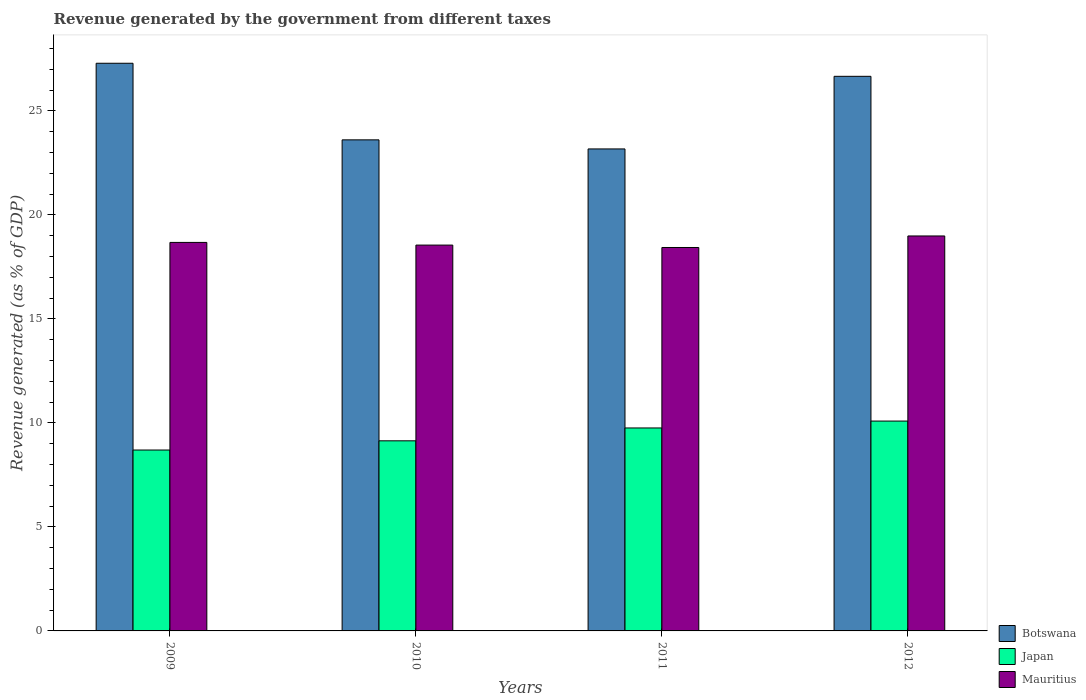Are the number of bars per tick equal to the number of legend labels?
Your answer should be very brief. Yes. Are the number of bars on each tick of the X-axis equal?
Offer a very short reply. Yes. How many bars are there on the 3rd tick from the right?
Offer a very short reply. 3. What is the label of the 1st group of bars from the left?
Give a very brief answer. 2009. In how many cases, is the number of bars for a given year not equal to the number of legend labels?
Make the answer very short. 0. What is the revenue generated by the government in Mauritius in 2009?
Provide a succinct answer. 18.67. Across all years, what is the maximum revenue generated by the government in Botswana?
Make the answer very short. 27.29. Across all years, what is the minimum revenue generated by the government in Botswana?
Ensure brevity in your answer.  23.17. In which year was the revenue generated by the government in Mauritius minimum?
Your answer should be compact. 2011. What is the total revenue generated by the government in Mauritius in the graph?
Provide a short and direct response. 74.64. What is the difference between the revenue generated by the government in Japan in 2010 and that in 2011?
Give a very brief answer. -0.62. What is the difference between the revenue generated by the government in Japan in 2009 and the revenue generated by the government in Mauritius in 2012?
Offer a terse response. -10.29. What is the average revenue generated by the government in Japan per year?
Provide a succinct answer. 9.42. In the year 2009, what is the difference between the revenue generated by the government in Botswana and revenue generated by the government in Mauritius?
Offer a very short reply. 8.61. What is the ratio of the revenue generated by the government in Mauritius in 2009 to that in 2011?
Ensure brevity in your answer.  1.01. What is the difference between the highest and the second highest revenue generated by the government in Botswana?
Give a very brief answer. 0.63. What is the difference between the highest and the lowest revenue generated by the government in Botswana?
Provide a succinct answer. 4.12. Is the sum of the revenue generated by the government in Mauritius in 2010 and 2012 greater than the maximum revenue generated by the government in Botswana across all years?
Keep it short and to the point. Yes. What does the 1st bar from the left in 2011 represents?
Give a very brief answer. Botswana. What does the 3rd bar from the right in 2012 represents?
Your answer should be compact. Botswana. Is it the case that in every year, the sum of the revenue generated by the government in Japan and revenue generated by the government in Botswana is greater than the revenue generated by the government in Mauritius?
Your answer should be very brief. Yes. How many bars are there?
Keep it short and to the point. 12. How many years are there in the graph?
Offer a terse response. 4. Does the graph contain grids?
Give a very brief answer. No. Where does the legend appear in the graph?
Give a very brief answer. Bottom right. What is the title of the graph?
Your response must be concise. Revenue generated by the government from different taxes. What is the label or title of the Y-axis?
Give a very brief answer. Revenue generated (as % of GDP). What is the Revenue generated (as % of GDP) in Botswana in 2009?
Offer a very short reply. 27.29. What is the Revenue generated (as % of GDP) in Japan in 2009?
Provide a succinct answer. 8.7. What is the Revenue generated (as % of GDP) in Mauritius in 2009?
Ensure brevity in your answer.  18.67. What is the Revenue generated (as % of GDP) in Botswana in 2010?
Give a very brief answer. 23.6. What is the Revenue generated (as % of GDP) in Japan in 2010?
Provide a short and direct response. 9.14. What is the Revenue generated (as % of GDP) of Mauritius in 2010?
Provide a short and direct response. 18.55. What is the Revenue generated (as % of GDP) in Botswana in 2011?
Offer a very short reply. 23.17. What is the Revenue generated (as % of GDP) in Japan in 2011?
Keep it short and to the point. 9.76. What is the Revenue generated (as % of GDP) in Mauritius in 2011?
Keep it short and to the point. 18.43. What is the Revenue generated (as % of GDP) of Botswana in 2012?
Offer a very short reply. 26.66. What is the Revenue generated (as % of GDP) of Japan in 2012?
Your answer should be compact. 10.09. What is the Revenue generated (as % of GDP) of Mauritius in 2012?
Offer a terse response. 18.98. Across all years, what is the maximum Revenue generated (as % of GDP) in Botswana?
Provide a short and direct response. 27.29. Across all years, what is the maximum Revenue generated (as % of GDP) in Japan?
Your answer should be very brief. 10.09. Across all years, what is the maximum Revenue generated (as % of GDP) of Mauritius?
Your response must be concise. 18.98. Across all years, what is the minimum Revenue generated (as % of GDP) in Botswana?
Offer a very short reply. 23.17. Across all years, what is the minimum Revenue generated (as % of GDP) in Japan?
Your response must be concise. 8.7. Across all years, what is the minimum Revenue generated (as % of GDP) of Mauritius?
Offer a terse response. 18.43. What is the total Revenue generated (as % of GDP) in Botswana in the graph?
Keep it short and to the point. 100.72. What is the total Revenue generated (as % of GDP) in Japan in the graph?
Your response must be concise. 37.68. What is the total Revenue generated (as % of GDP) in Mauritius in the graph?
Your answer should be compact. 74.64. What is the difference between the Revenue generated (as % of GDP) of Botswana in 2009 and that in 2010?
Your answer should be very brief. 3.68. What is the difference between the Revenue generated (as % of GDP) of Japan in 2009 and that in 2010?
Your answer should be very brief. -0.44. What is the difference between the Revenue generated (as % of GDP) in Mauritius in 2009 and that in 2010?
Make the answer very short. 0.13. What is the difference between the Revenue generated (as % of GDP) in Botswana in 2009 and that in 2011?
Provide a short and direct response. 4.12. What is the difference between the Revenue generated (as % of GDP) of Japan in 2009 and that in 2011?
Make the answer very short. -1.06. What is the difference between the Revenue generated (as % of GDP) in Mauritius in 2009 and that in 2011?
Your answer should be very brief. 0.24. What is the difference between the Revenue generated (as % of GDP) of Botswana in 2009 and that in 2012?
Make the answer very short. 0.63. What is the difference between the Revenue generated (as % of GDP) in Japan in 2009 and that in 2012?
Give a very brief answer. -1.39. What is the difference between the Revenue generated (as % of GDP) in Mauritius in 2009 and that in 2012?
Provide a succinct answer. -0.31. What is the difference between the Revenue generated (as % of GDP) of Botswana in 2010 and that in 2011?
Provide a short and direct response. 0.44. What is the difference between the Revenue generated (as % of GDP) in Japan in 2010 and that in 2011?
Offer a very short reply. -0.62. What is the difference between the Revenue generated (as % of GDP) in Mauritius in 2010 and that in 2011?
Ensure brevity in your answer.  0.12. What is the difference between the Revenue generated (as % of GDP) of Botswana in 2010 and that in 2012?
Provide a short and direct response. -3.05. What is the difference between the Revenue generated (as % of GDP) of Japan in 2010 and that in 2012?
Provide a short and direct response. -0.95. What is the difference between the Revenue generated (as % of GDP) in Mauritius in 2010 and that in 2012?
Your response must be concise. -0.44. What is the difference between the Revenue generated (as % of GDP) in Botswana in 2011 and that in 2012?
Your answer should be very brief. -3.49. What is the difference between the Revenue generated (as % of GDP) of Japan in 2011 and that in 2012?
Your response must be concise. -0.33. What is the difference between the Revenue generated (as % of GDP) of Mauritius in 2011 and that in 2012?
Your response must be concise. -0.55. What is the difference between the Revenue generated (as % of GDP) in Botswana in 2009 and the Revenue generated (as % of GDP) in Japan in 2010?
Give a very brief answer. 18.15. What is the difference between the Revenue generated (as % of GDP) of Botswana in 2009 and the Revenue generated (as % of GDP) of Mauritius in 2010?
Give a very brief answer. 8.74. What is the difference between the Revenue generated (as % of GDP) of Japan in 2009 and the Revenue generated (as % of GDP) of Mauritius in 2010?
Keep it short and to the point. -9.85. What is the difference between the Revenue generated (as % of GDP) of Botswana in 2009 and the Revenue generated (as % of GDP) of Japan in 2011?
Offer a terse response. 17.53. What is the difference between the Revenue generated (as % of GDP) in Botswana in 2009 and the Revenue generated (as % of GDP) in Mauritius in 2011?
Your response must be concise. 8.86. What is the difference between the Revenue generated (as % of GDP) of Japan in 2009 and the Revenue generated (as % of GDP) of Mauritius in 2011?
Offer a terse response. -9.74. What is the difference between the Revenue generated (as % of GDP) of Botswana in 2009 and the Revenue generated (as % of GDP) of Japan in 2012?
Offer a very short reply. 17.2. What is the difference between the Revenue generated (as % of GDP) in Botswana in 2009 and the Revenue generated (as % of GDP) in Mauritius in 2012?
Your answer should be compact. 8.3. What is the difference between the Revenue generated (as % of GDP) in Japan in 2009 and the Revenue generated (as % of GDP) in Mauritius in 2012?
Make the answer very short. -10.29. What is the difference between the Revenue generated (as % of GDP) of Botswana in 2010 and the Revenue generated (as % of GDP) of Japan in 2011?
Ensure brevity in your answer.  13.85. What is the difference between the Revenue generated (as % of GDP) of Botswana in 2010 and the Revenue generated (as % of GDP) of Mauritius in 2011?
Your answer should be very brief. 5.17. What is the difference between the Revenue generated (as % of GDP) in Japan in 2010 and the Revenue generated (as % of GDP) in Mauritius in 2011?
Offer a terse response. -9.29. What is the difference between the Revenue generated (as % of GDP) of Botswana in 2010 and the Revenue generated (as % of GDP) of Japan in 2012?
Offer a terse response. 13.52. What is the difference between the Revenue generated (as % of GDP) of Botswana in 2010 and the Revenue generated (as % of GDP) of Mauritius in 2012?
Make the answer very short. 4.62. What is the difference between the Revenue generated (as % of GDP) of Japan in 2010 and the Revenue generated (as % of GDP) of Mauritius in 2012?
Keep it short and to the point. -9.85. What is the difference between the Revenue generated (as % of GDP) in Botswana in 2011 and the Revenue generated (as % of GDP) in Japan in 2012?
Your answer should be very brief. 13.08. What is the difference between the Revenue generated (as % of GDP) in Botswana in 2011 and the Revenue generated (as % of GDP) in Mauritius in 2012?
Provide a short and direct response. 4.18. What is the difference between the Revenue generated (as % of GDP) of Japan in 2011 and the Revenue generated (as % of GDP) of Mauritius in 2012?
Make the answer very short. -9.23. What is the average Revenue generated (as % of GDP) in Botswana per year?
Provide a short and direct response. 25.18. What is the average Revenue generated (as % of GDP) of Japan per year?
Your answer should be very brief. 9.42. What is the average Revenue generated (as % of GDP) in Mauritius per year?
Make the answer very short. 18.66. In the year 2009, what is the difference between the Revenue generated (as % of GDP) in Botswana and Revenue generated (as % of GDP) in Japan?
Keep it short and to the point. 18.59. In the year 2009, what is the difference between the Revenue generated (as % of GDP) of Botswana and Revenue generated (as % of GDP) of Mauritius?
Ensure brevity in your answer.  8.61. In the year 2009, what is the difference between the Revenue generated (as % of GDP) of Japan and Revenue generated (as % of GDP) of Mauritius?
Keep it short and to the point. -9.98. In the year 2010, what is the difference between the Revenue generated (as % of GDP) of Botswana and Revenue generated (as % of GDP) of Japan?
Your answer should be very brief. 14.47. In the year 2010, what is the difference between the Revenue generated (as % of GDP) in Botswana and Revenue generated (as % of GDP) in Mauritius?
Ensure brevity in your answer.  5.06. In the year 2010, what is the difference between the Revenue generated (as % of GDP) in Japan and Revenue generated (as % of GDP) in Mauritius?
Keep it short and to the point. -9.41. In the year 2011, what is the difference between the Revenue generated (as % of GDP) of Botswana and Revenue generated (as % of GDP) of Japan?
Ensure brevity in your answer.  13.41. In the year 2011, what is the difference between the Revenue generated (as % of GDP) in Botswana and Revenue generated (as % of GDP) in Mauritius?
Give a very brief answer. 4.74. In the year 2011, what is the difference between the Revenue generated (as % of GDP) of Japan and Revenue generated (as % of GDP) of Mauritius?
Ensure brevity in your answer.  -8.67. In the year 2012, what is the difference between the Revenue generated (as % of GDP) of Botswana and Revenue generated (as % of GDP) of Japan?
Offer a terse response. 16.57. In the year 2012, what is the difference between the Revenue generated (as % of GDP) in Botswana and Revenue generated (as % of GDP) in Mauritius?
Your answer should be compact. 7.67. In the year 2012, what is the difference between the Revenue generated (as % of GDP) of Japan and Revenue generated (as % of GDP) of Mauritius?
Offer a terse response. -8.9. What is the ratio of the Revenue generated (as % of GDP) of Botswana in 2009 to that in 2010?
Ensure brevity in your answer.  1.16. What is the ratio of the Revenue generated (as % of GDP) of Japan in 2009 to that in 2010?
Ensure brevity in your answer.  0.95. What is the ratio of the Revenue generated (as % of GDP) in Mauritius in 2009 to that in 2010?
Give a very brief answer. 1.01. What is the ratio of the Revenue generated (as % of GDP) of Botswana in 2009 to that in 2011?
Make the answer very short. 1.18. What is the ratio of the Revenue generated (as % of GDP) in Japan in 2009 to that in 2011?
Ensure brevity in your answer.  0.89. What is the ratio of the Revenue generated (as % of GDP) of Mauritius in 2009 to that in 2011?
Provide a short and direct response. 1.01. What is the ratio of the Revenue generated (as % of GDP) of Botswana in 2009 to that in 2012?
Keep it short and to the point. 1.02. What is the ratio of the Revenue generated (as % of GDP) of Japan in 2009 to that in 2012?
Make the answer very short. 0.86. What is the ratio of the Revenue generated (as % of GDP) of Mauritius in 2009 to that in 2012?
Give a very brief answer. 0.98. What is the ratio of the Revenue generated (as % of GDP) in Botswana in 2010 to that in 2011?
Give a very brief answer. 1.02. What is the ratio of the Revenue generated (as % of GDP) of Japan in 2010 to that in 2011?
Your answer should be compact. 0.94. What is the ratio of the Revenue generated (as % of GDP) in Botswana in 2010 to that in 2012?
Offer a terse response. 0.89. What is the ratio of the Revenue generated (as % of GDP) in Japan in 2010 to that in 2012?
Your answer should be very brief. 0.91. What is the ratio of the Revenue generated (as % of GDP) of Mauritius in 2010 to that in 2012?
Provide a succinct answer. 0.98. What is the ratio of the Revenue generated (as % of GDP) of Botswana in 2011 to that in 2012?
Offer a terse response. 0.87. What is the ratio of the Revenue generated (as % of GDP) of Japan in 2011 to that in 2012?
Your response must be concise. 0.97. What is the ratio of the Revenue generated (as % of GDP) of Mauritius in 2011 to that in 2012?
Give a very brief answer. 0.97. What is the difference between the highest and the second highest Revenue generated (as % of GDP) of Botswana?
Give a very brief answer. 0.63. What is the difference between the highest and the second highest Revenue generated (as % of GDP) of Japan?
Give a very brief answer. 0.33. What is the difference between the highest and the second highest Revenue generated (as % of GDP) in Mauritius?
Keep it short and to the point. 0.31. What is the difference between the highest and the lowest Revenue generated (as % of GDP) in Botswana?
Offer a very short reply. 4.12. What is the difference between the highest and the lowest Revenue generated (as % of GDP) of Japan?
Ensure brevity in your answer.  1.39. What is the difference between the highest and the lowest Revenue generated (as % of GDP) of Mauritius?
Your answer should be compact. 0.55. 